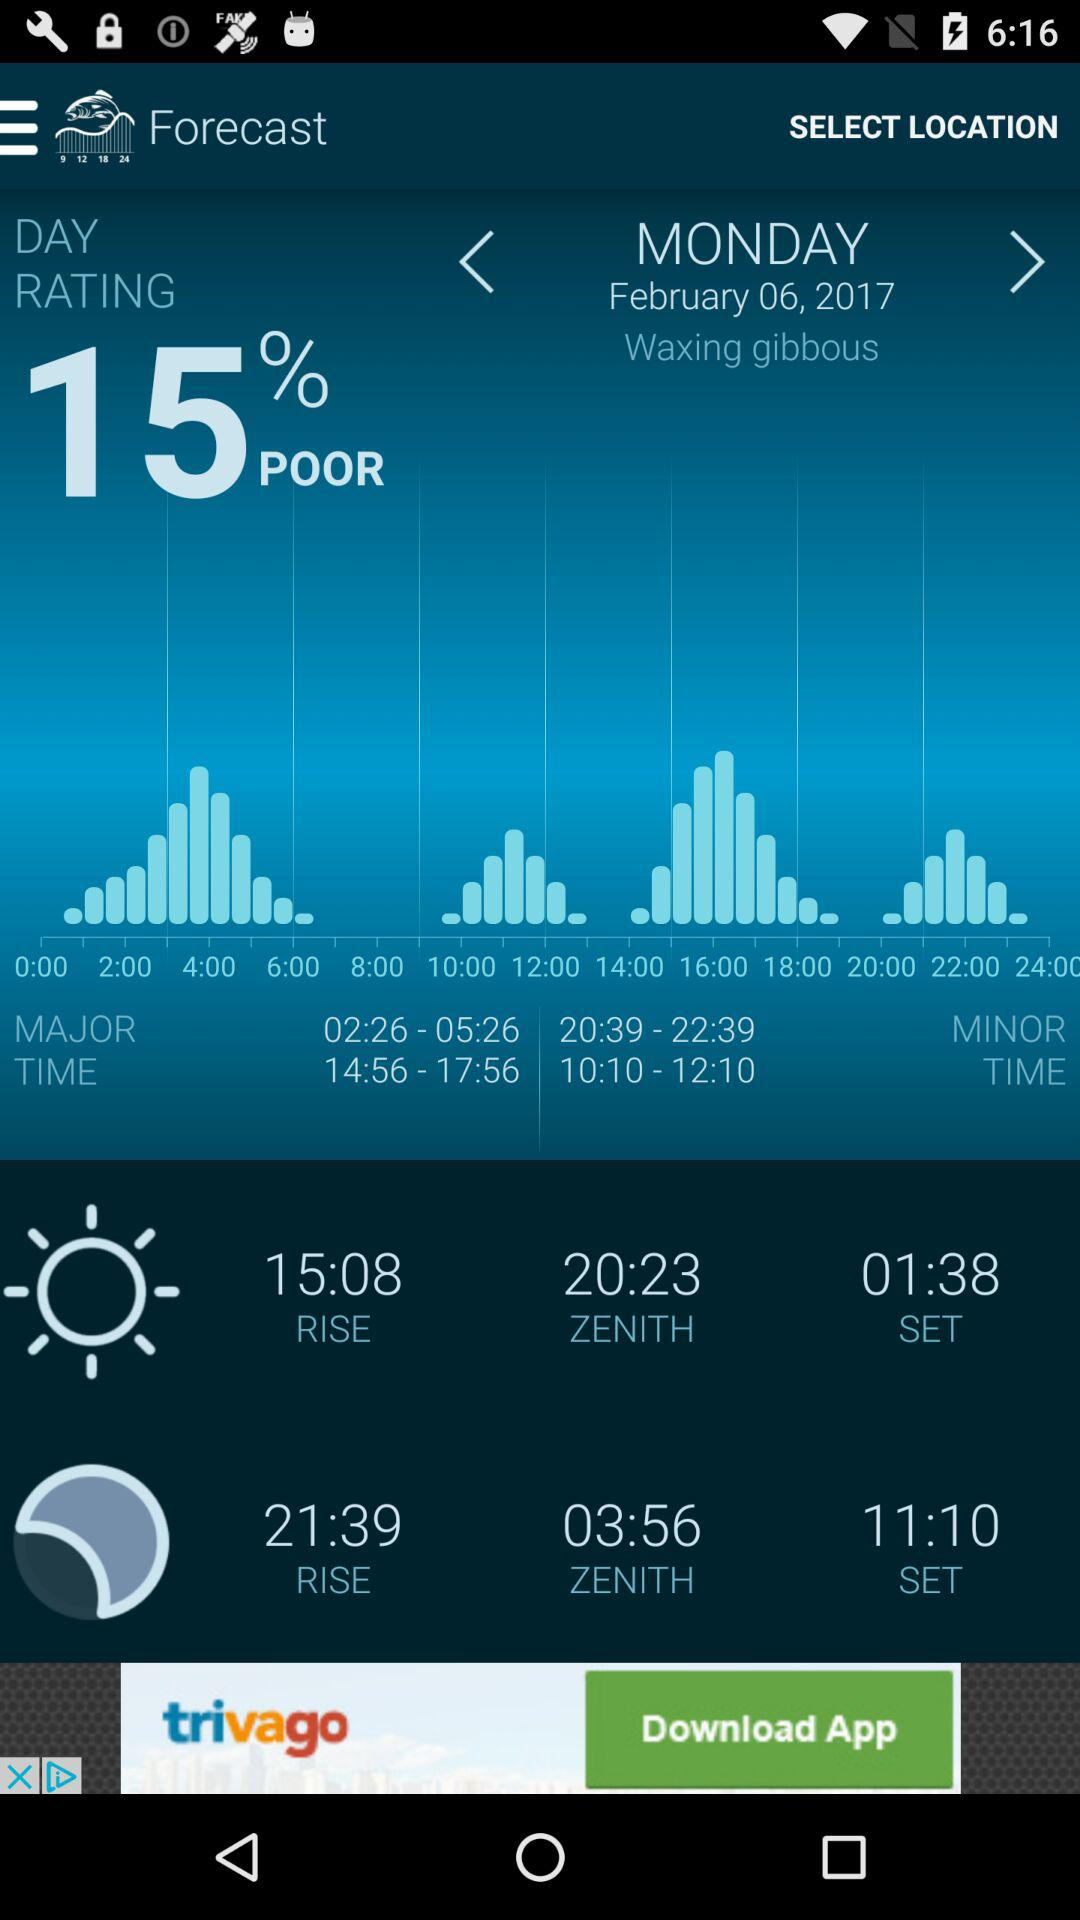What is the minor timing? The minor timings are 20:39-22:39 and 10:10-12:10. 